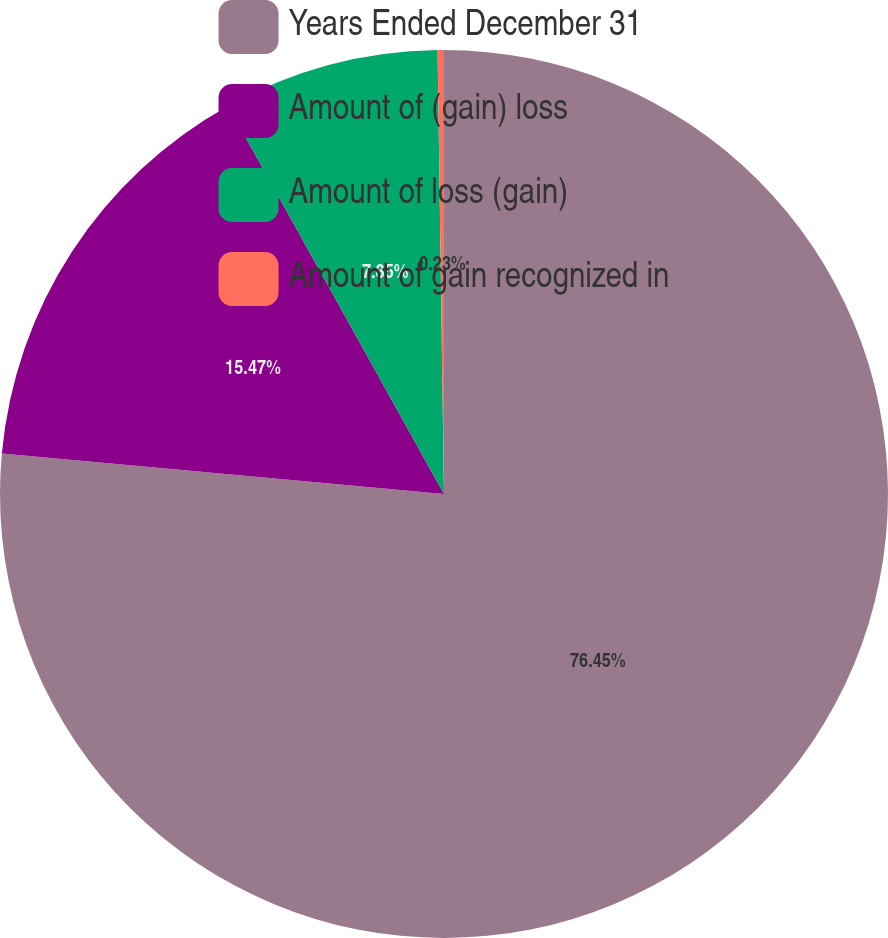Convert chart to OTSL. <chart><loc_0><loc_0><loc_500><loc_500><pie_chart><fcel>Years Ended December 31<fcel>Amount of (gain) loss<fcel>Amount of loss (gain)<fcel>Amount of gain recognized in<nl><fcel>76.45%<fcel>15.47%<fcel>7.85%<fcel>0.23%<nl></chart> 